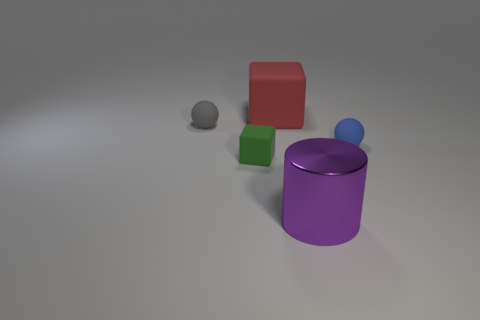The big rubber thing is what shape?
Make the answer very short. Cube. Are the tiny gray sphere and the big cube that is behind the gray ball made of the same material?
Make the answer very short. Yes. How many rubber objects are big yellow spheres or red things?
Offer a terse response. 1. What size is the metal cylinder that is right of the tiny gray matte sphere?
Give a very brief answer. Large. What size is the red cube that is the same material as the blue ball?
Your response must be concise. Large. Is there a red thing?
Provide a succinct answer. Yes. Is the shape of the green matte thing the same as the large thing that is behind the blue thing?
Give a very brief answer. Yes. There is a matte cube behind the small rubber object that is in front of the tiny rubber ball in front of the tiny gray rubber thing; what is its color?
Offer a terse response. Red. Are there any tiny spheres in front of the small blue ball?
Offer a terse response. No. Are there any large red things that have the same material as the green object?
Offer a terse response. Yes. 